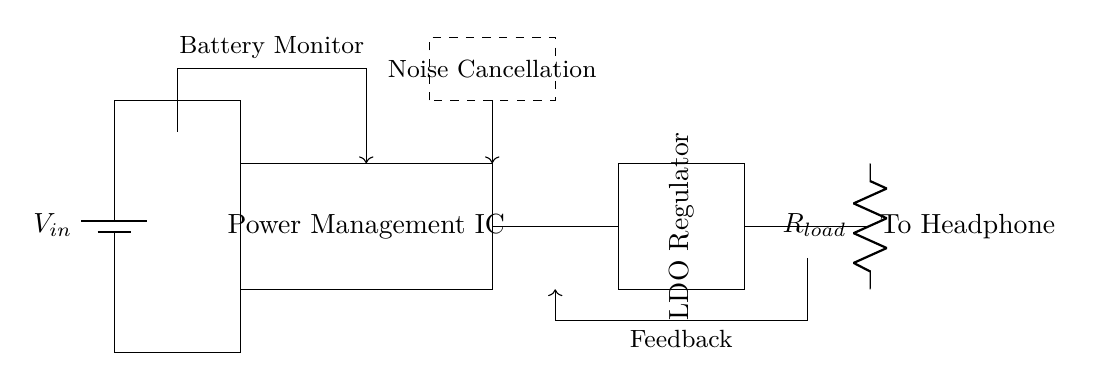What is the component that regulates voltage in this circuit? The voltage regulator is represented as an LDO (Low Drop-Out) Regulator, which is specifically designed to maintain a steady voltage output despite variations in load current and input voltage.
Answer: LDO Regulator What is the purpose of the battery monitor in this circuit? The battery monitor is used to keep track of the battery's voltage level and health, ensuring the power management circuit responds appropriately to changes, especially to prevent battery over-discharge.
Answer: Battery Monitor How many components are used before reaching the Load Resistor? There are three main components before the Load Resistor: the power source, the power management IC, and the voltage regulator, demonstrating the pathway for voltage regulation before powering the load.
Answer: Three What additional function does the feedback in this circuit serve? The feedback loop allows the voltage regulator to adjust its output based on the actual load conditions, thus ensuring stable power delivery and optimal performance for the noise-cancellation system.
Answer: Voltage stabilization What is the role of the dashed box in the diagram? The dashed box encloses the noise cancellation block, indicating its function within the circuit; this block is critical for actively managing noise filtering and improving the user experience by reducing unwanted sounds.
Answer: Noise Cancellation What does the resistor labeled R_load signify in this circuit? The resistor labeled R_load represents the load connected to the output of the voltage regulator, which effectively simulates the impedance presented by the headphones connected to the power management circuit.
Answer: Load Resistor 